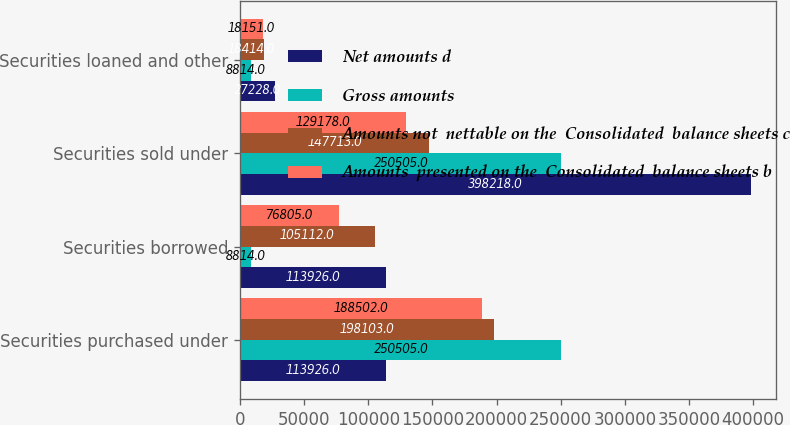Convert chart. <chart><loc_0><loc_0><loc_500><loc_500><stacked_bar_chart><ecel><fcel>Securities purchased under<fcel>Securities borrowed<fcel>Securities sold under<fcel>Securities loaned and other<nl><fcel>Net amounts d<fcel>113926<fcel>113926<fcel>398218<fcel>27228<nl><fcel>Gross amounts<fcel>250505<fcel>8814<fcel>250505<fcel>8814<nl><fcel>Amounts not  nettable on the  Consolidated  balance sheets c<fcel>198103<fcel>105112<fcel>147713<fcel>18414<nl><fcel>Amounts  presented on the  Consolidated  balance sheets b<fcel>188502<fcel>76805<fcel>129178<fcel>18151<nl></chart> 